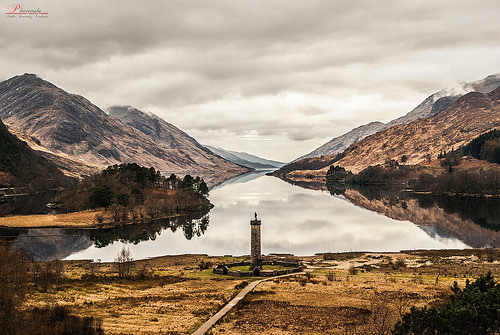<image>
Is the water under the cloud? Yes. The water is positioned underneath the cloud, with the cloud above it in the vertical space. 